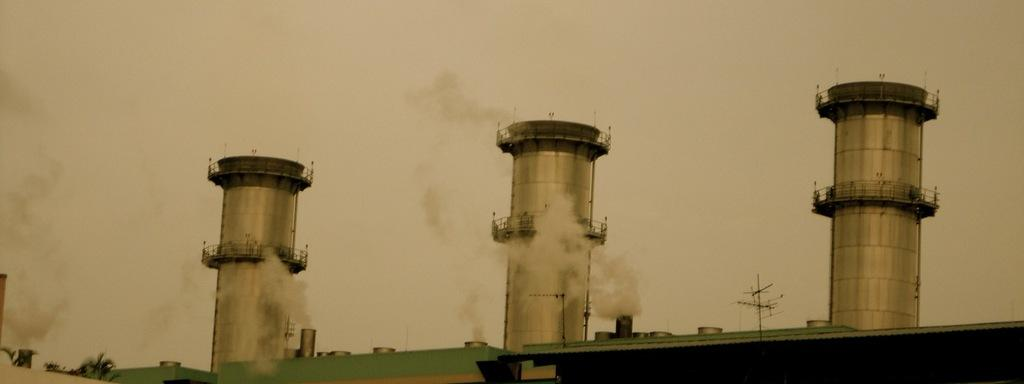What structures are visible in the image? There are chimneys in the image. What is happening with the chimneys? Smoke is coming out of the chimneys. What type of jelly can be seen in the image? There is no jelly present in the image; it features chimneys with smoke coming out of them. Is there a church visible in the image? There is no church present in the image; it only shows chimneys with smoke. 